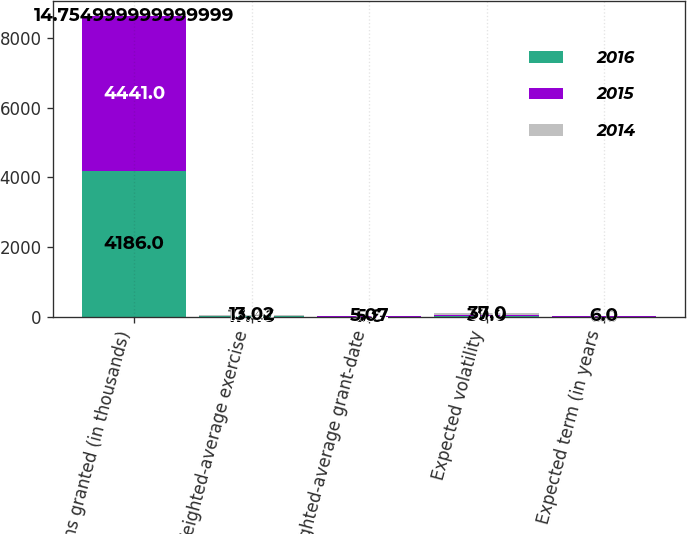Convert chart to OTSL. <chart><loc_0><loc_0><loc_500><loc_500><stacked_bar_chart><ecel><fcel>Options granted (in thousands)<fcel>Weighted-average exercise<fcel>Weighted-average grant-date<fcel>Expected volatility<fcel>Expected term (in years<nl><fcel>2016<fcel>4186<fcel>17.46<fcel>5.6<fcel>30<fcel>6<nl><fcel>2015<fcel>4441<fcel>16.49<fcel>5.54<fcel>31<fcel>6<nl><fcel>2014<fcel>14.755<fcel>13.02<fcel>5.07<fcel>37<fcel>6<nl></chart> 